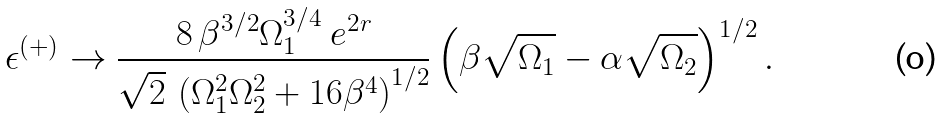<formula> <loc_0><loc_0><loc_500><loc_500>\epsilon ^ { ( + ) } \rightarrow \frac { 8 \, \beta ^ { 3 / 2 } \Omega _ { 1 } ^ { 3 / 4 } \ e ^ { 2 r } } { \sqrt { 2 } \, \left ( \Omega _ { 1 } ^ { 2 } \Omega _ { 2 } ^ { 2 } + 1 6 \beta ^ { 4 } \right ) ^ { 1 / 2 } } \left ( \beta \sqrt { \Omega _ { 1 } } - \alpha \sqrt { \Omega _ { 2 } } \right ) ^ { 1 / 2 } .</formula> 